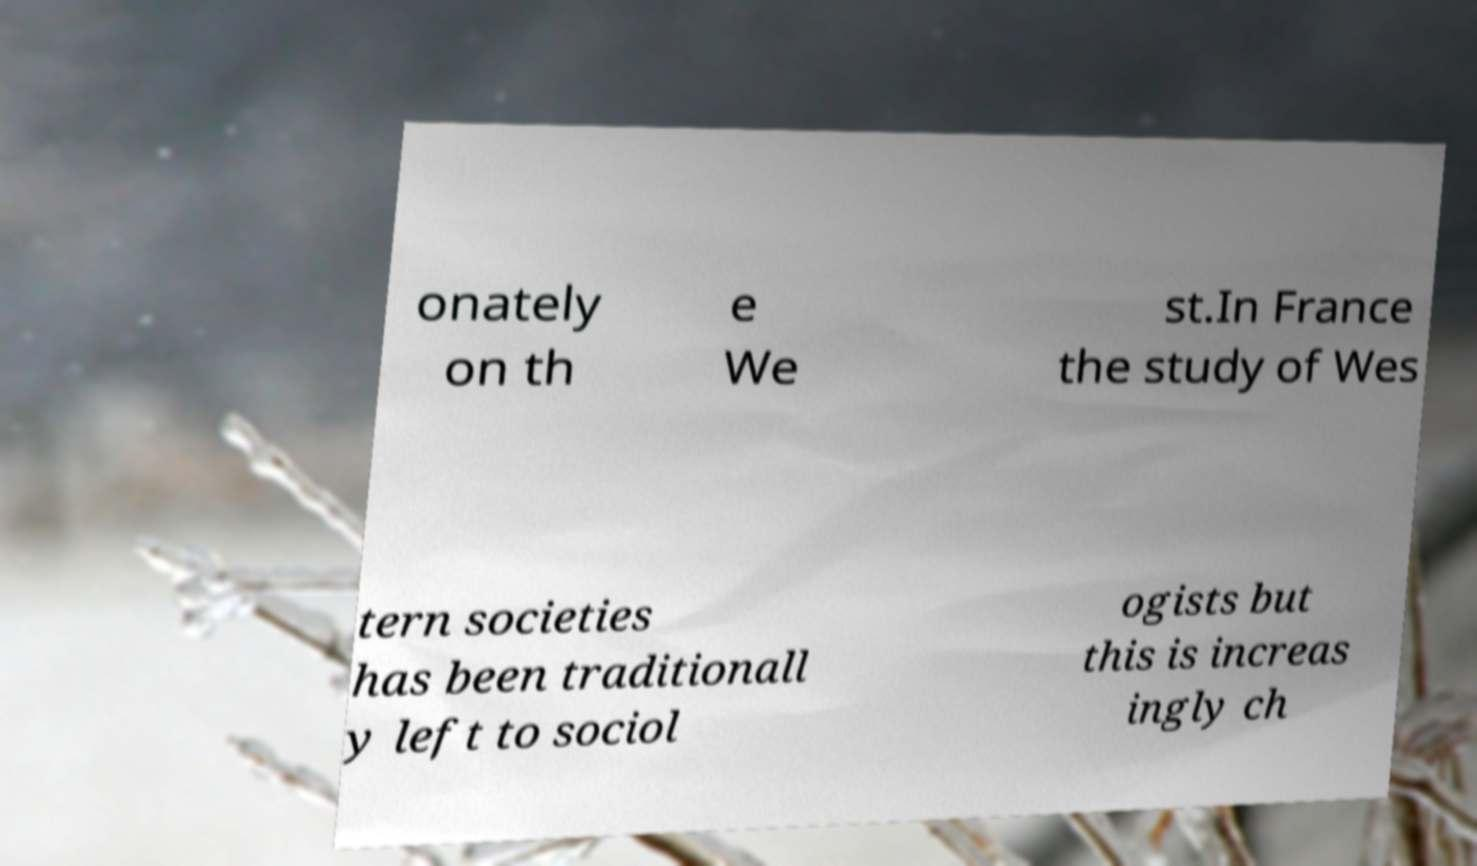I need the written content from this picture converted into text. Can you do that? onately on th e We st.In France the study of Wes tern societies has been traditionall y left to sociol ogists but this is increas ingly ch 